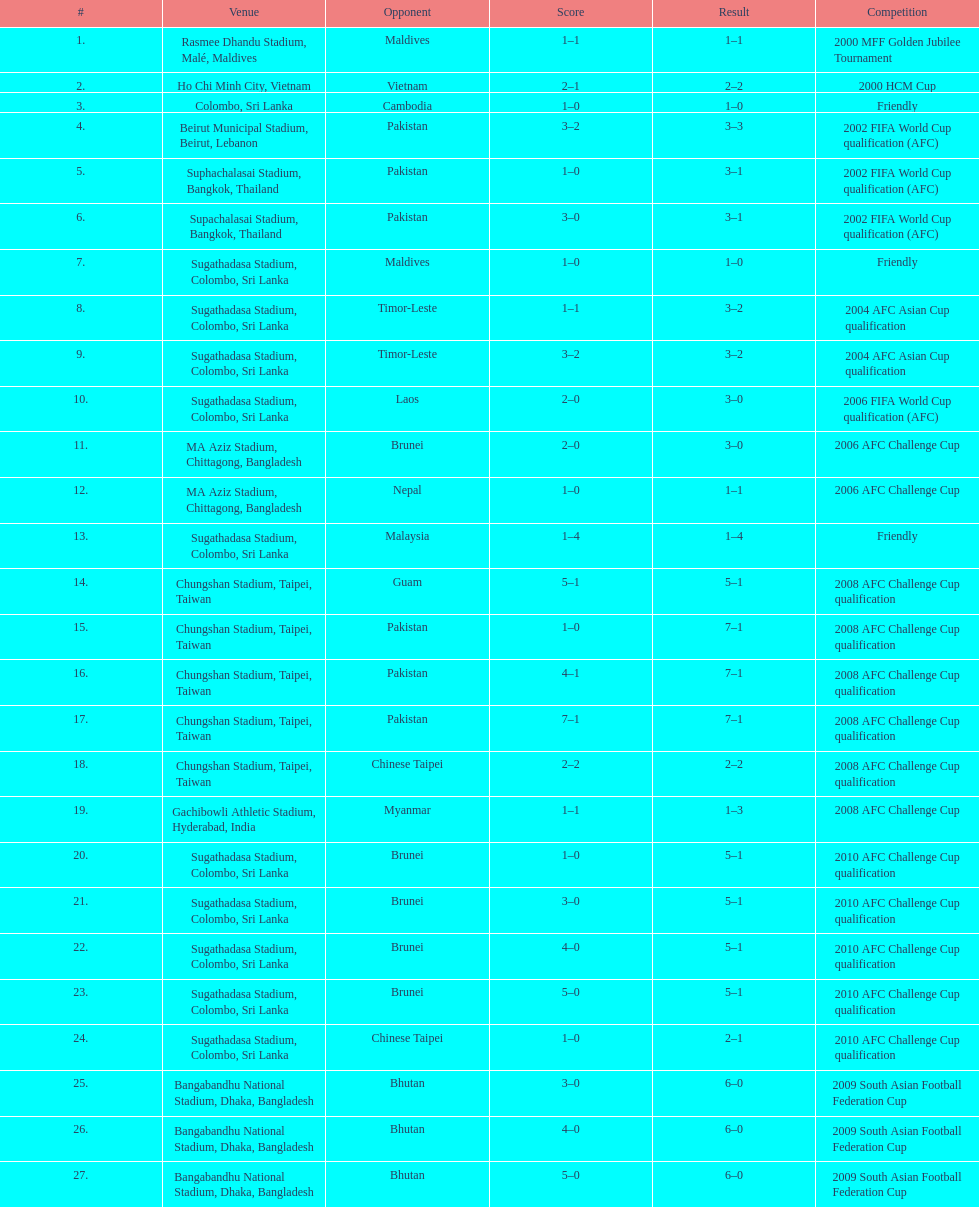What was the overall goal count in the sri lanka vs. malaysia match on march 24, 2007? 5. 